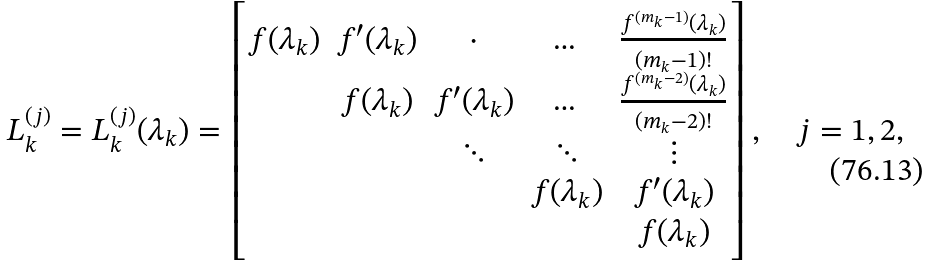Convert formula to latex. <formula><loc_0><loc_0><loc_500><loc_500>L _ { k } ^ { ( j ) } = L _ { k } ^ { ( j ) } ( \lambda _ { k } ) = \begin{bmatrix} f ( \lambda _ { k } ) & f ^ { \prime } ( \lambda _ { k } ) & \cdot & \dots & \frac { f ^ { ( m _ { k } - 1 ) } ( \lambda _ { k } ) } { ( m _ { k } - 1 ) ! } \\ & f ( \lambda _ { k } ) & f ^ { \prime } ( \lambda _ { k } ) & \dots & \frac { f ^ { ( m _ { k } - 2 ) } ( \lambda _ { k } ) } { ( m _ { k } - 2 ) ! } \\ & & \ddots & \ddots & \vdots \\ & & & f ( \lambda _ { k } ) & f ^ { \prime } ( \lambda _ { k } ) \\ & & & & f ( \lambda _ { k } ) \end{bmatrix} , \quad j = 1 , 2 ,</formula> 